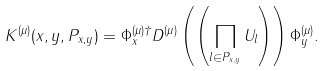<formula> <loc_0><loc_0><loc_500><loc_500>K ^ { ( \mu ) } ( x , y , P _ { x , y } ) = \Phi _ { x } ^ { ( \mu ) \dagger } D ^ { ( \mu ) } \left ( \left ( \prod _ { l \in P _ { x , y } } U _ { l } \right ) \right ) \Phi _ { y } ^ { ( \mu ) } .</formula> 